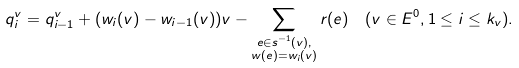<formula> <loc_0><loc_0><loc_500><loc_500>& q _ { i } ^ { v } = q ^ { v } _ { i - 1 } + ( w _ { i } ( v ) - w _ { i - 1 } ( v ) ) v - \sum _ { \substack { e \in s ^ { - 1 } ( v ) , \\ w ( e ) = w _ { i } ( v ) } } r ( e ) \quad ( v \in E ^ { 0 } , 1 \leq i \leq k _ { v } ) .</formula> 